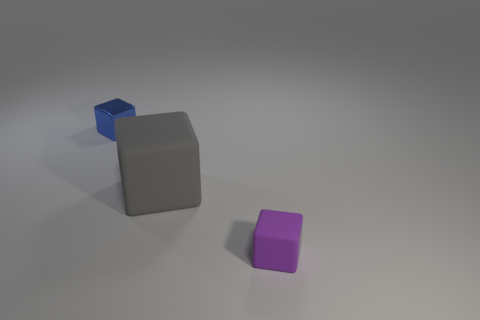Are there any other things that are the same size as the gray matte object?
Give a very brief answer. No. What shape is the rubber thing that is left of the thing that is right of the big gray matte object?
Offer a terse response. Cube. The metallic thing that is the same shape as the gray rubber thing is what size?
Offer a terse response. Small. There is a tiny cube that is to the left of the gray block; what is its color?
Offer a very short reply. Blue. What is the material of the tiny block that is in front of the rubber block that is left of the small cube right of the metal block?
Make the answer very short. Rubber. How big is the blue shiny block that is on the left side of the small thing that is in front of the blue shiny block?
Give a very brief answer. Small. What color is the other matte thing that is the same shape as the big gray object?
Make the answer very short. Purple. Do the blue shiny cube and the gray cube have the same size?
Offer a very short reply. No. What is the tiny blue thing made of?
Offer a very short reply. Metal. The other cube that is the same material as the purple cube is what color?
Give a very brief answer. Gray. 